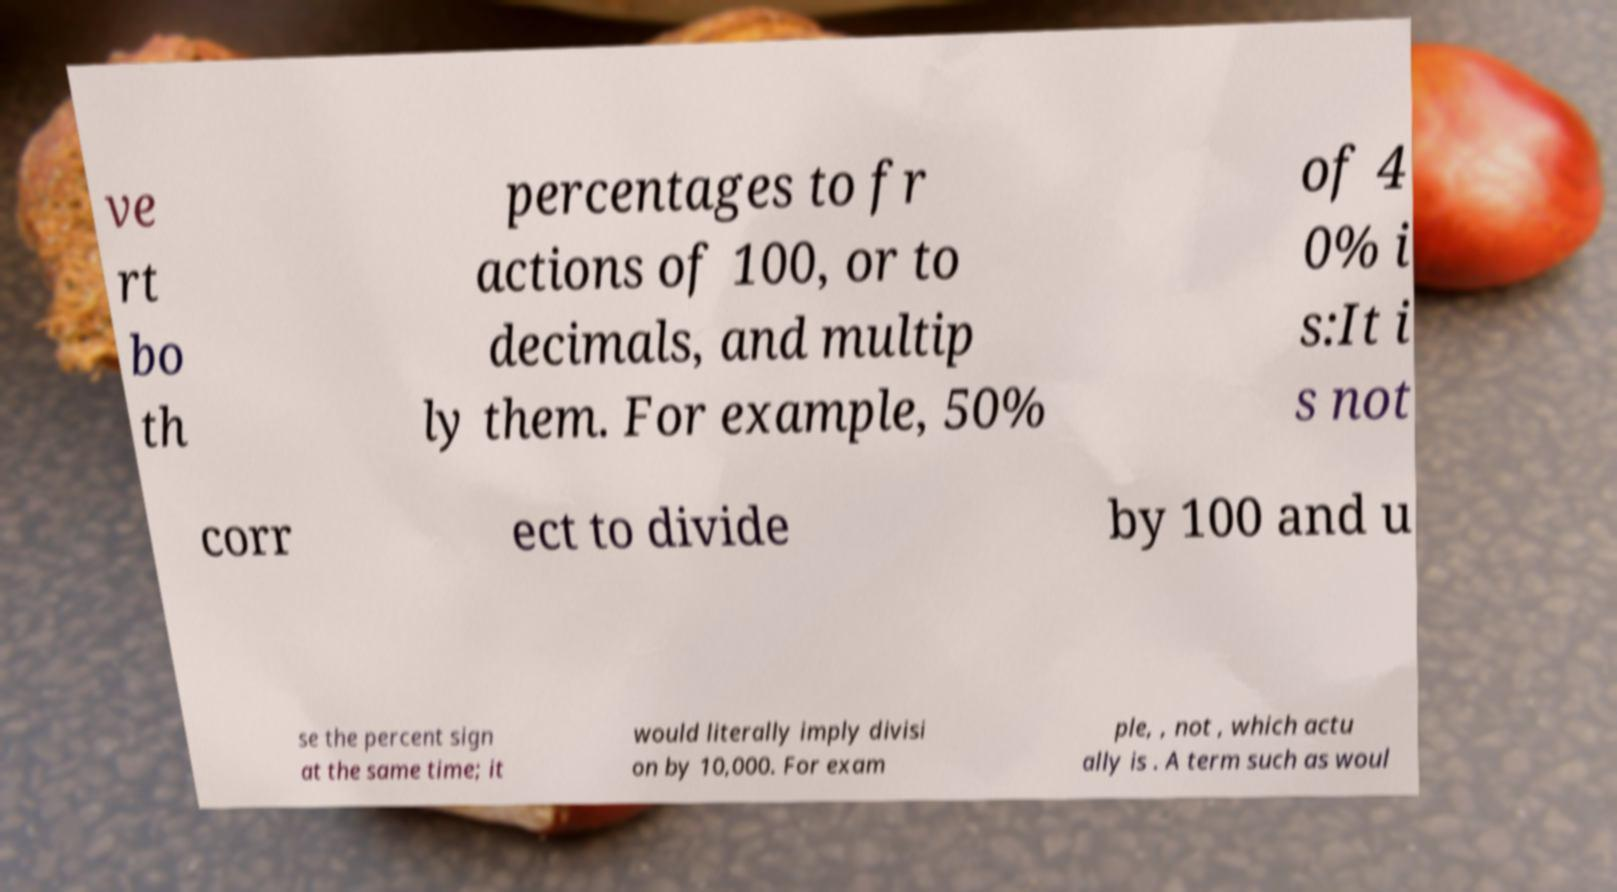I need the written content from this picture converted into text. Can you do that? ve rt bo th percentages to fr actions of 100, or to decimals, and multip ly them. For example, 50% of 4 0% i s:It i s not corr ect to divide by 100 and u se the percent sign at the same time; it would literally imply divisi on by 10,000. For exam ple, , not , which actu ally is . A term such as woul 